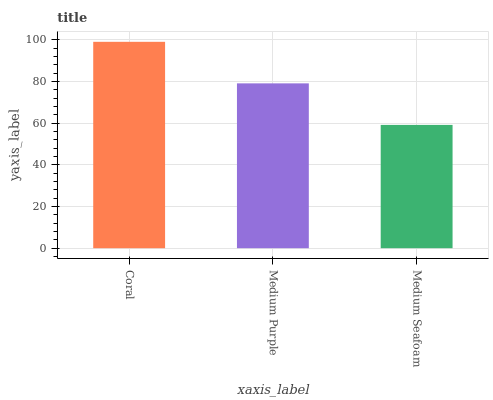Is Medium Purple the minimum?
Answer yes or no. No. Is Medium Purple the maximum?
Answer yes or no. No. Is Coral greater than Medium Purple?
Answer yes or no. Yes. Is Medium Purple less than Coral?
Answer yes or no. Yes. Is Medium Purple greater than Coral?
Answer yes or no. No. Is Coral less than Medium Purple?
Answer yes or no. No. Is Medium Purple the high median?
Answer yes or no. Yes. Is Medium Purple the low median?
Answer yes or no. Yes. Is Coral the high median?
Answer yes or no. No. Is Coral the low median?
Answer yes or no. No. 